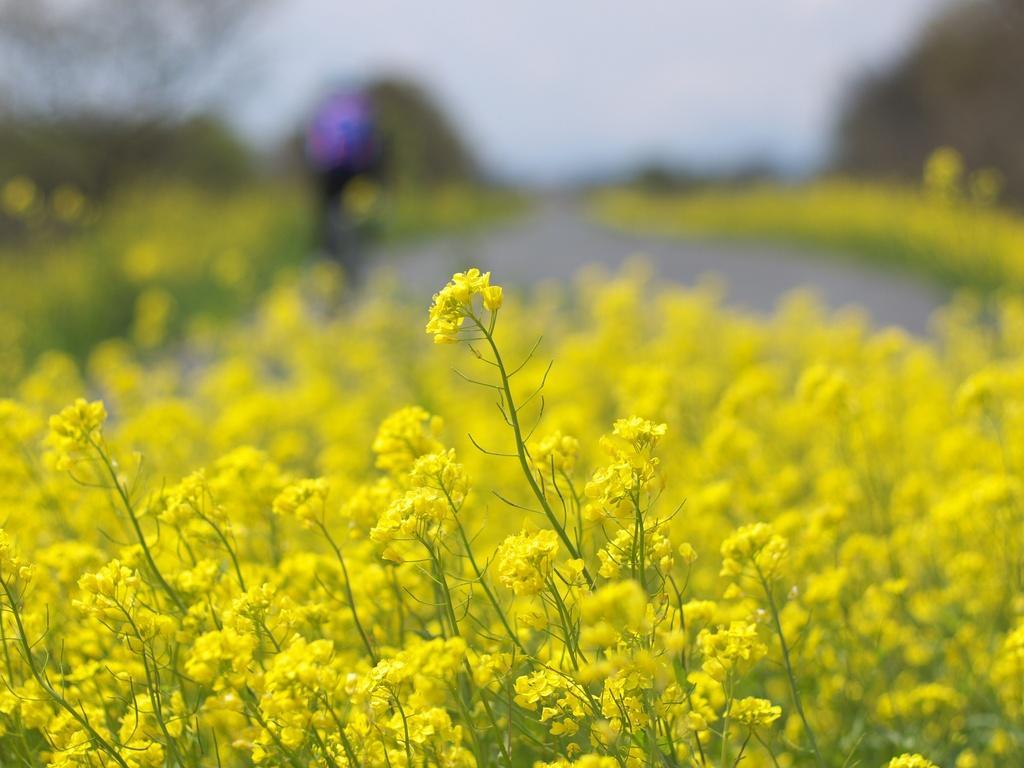In one or two sentences, can you explain what this image depicts? Bottom of the image there are some plants and flowers. Background of the image is blur. 